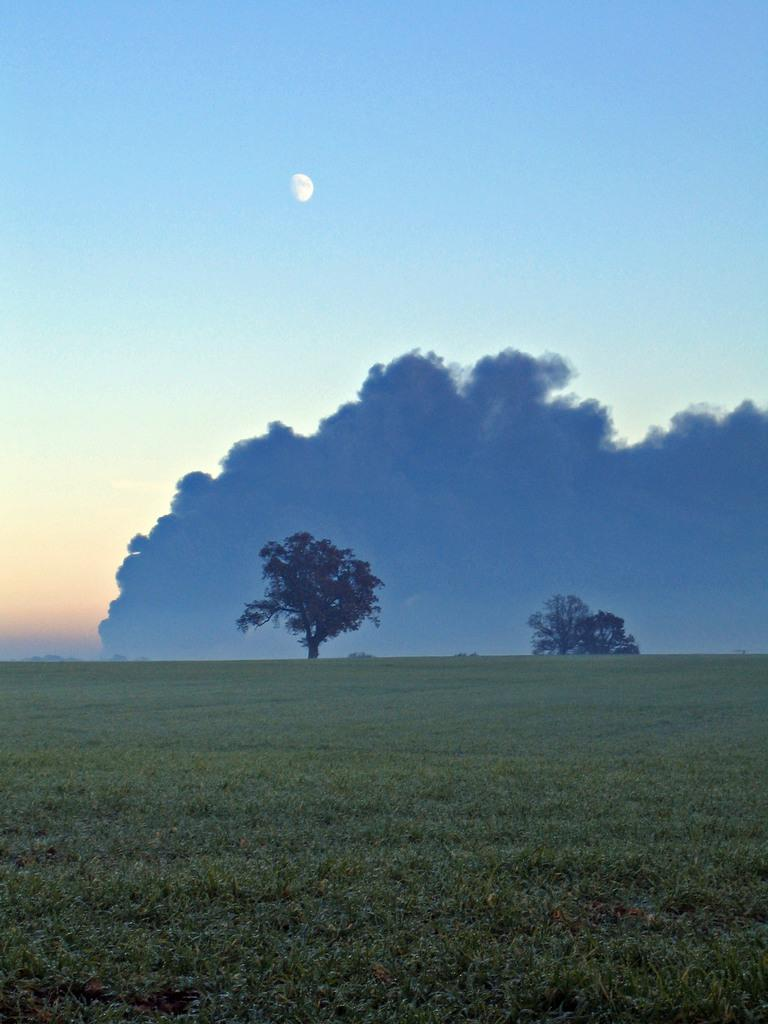What type of vegetation can be seen in the image? There is green grass in the image. What other natural elements are present in the image? There are trees in the image. What can be seen in the sky in the image? The sky is visible in the image, and there is a moon and clouds present. Can you see a person running on the grass in the image? There is no person running on the grass in the image. What type of sheet is covering the trees in the image? There is no sheet present in the image; the trees are not covered. 